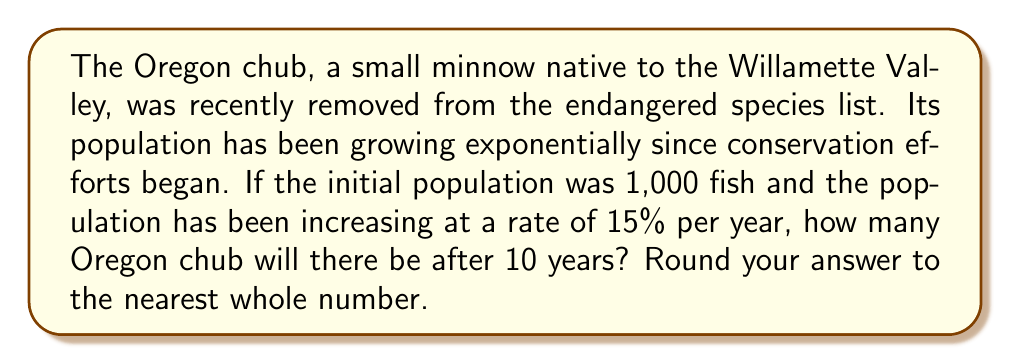Can you solve this math problem? To solve this problem, we'll use the exponential growth formula:

$$P(t) = P_0 \cdot (1 + r)^t$$

Where:
$P(t)$ is the population at time $t$
$P_0$ is the initial population
$r$ is the growth rate (as a decimal)
$t$ is the time in years

Given:
$P_0 = 1,000$ (initial population)
$r = 0.15$ (15% growth rate)
$t = 10$ years

Let's substitute these values into the formula:

$$P(10) = 1,000 \cdot (1 + 0.15)^{10}$$

Now, let's calculate step-by-step:

1) First, calculate $(1 + 0.15)^{10}$:
   $$(1.15)^{10} \approx 4.0456$$

2) Multiply this by the initial population:
   $$1,000 \cdot 4.0456 = 4,045.6$$

3) Round to the nearest whole number:
   $$4,046$$

Therefore, after 10 years, there will be approximately 4,046 Oregon chub.
Answer: 4,046 Oregon chub 